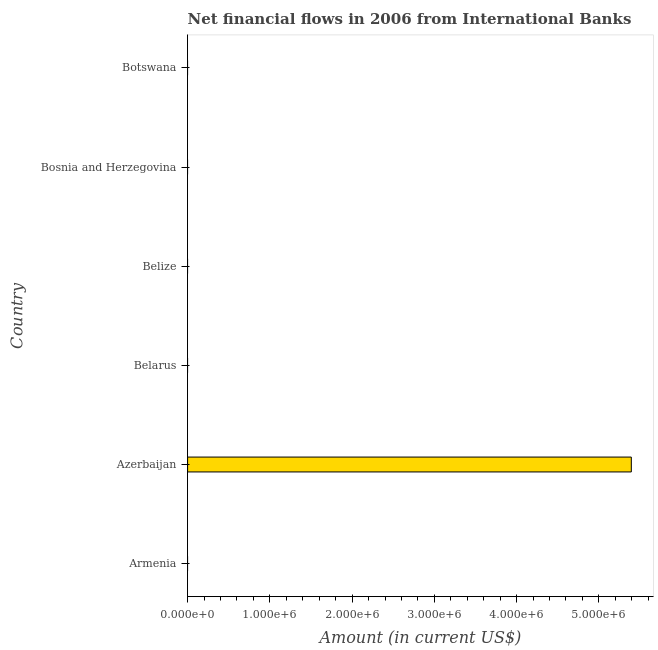Does the graph contain grids?
Make the answer very short. No. What is the title of the graph?
Offer a terse response. Net financial flows in 2006 from International Banks. What is the label or title of the X-axis?
Make the answer very short. Amount (in current US$). What is the label or title of the Y-axis?
Your answer should be very brief. Country. What is the net financial flows from ibrd in Azerbaijan?
Provide a succinct answer. 5.39e+06. Across all countries, what is the maximum net financial flows from ibrd?
Provide a succinct answer. 5.39e+06. In which country was the net financial flows from ibrd maximum?
Your answer should be very brief. Azerbaijan. What is the sum of the net financial flows from ibrd?
Provide a succinct answer. 5.39e+06. What is the average net financial flows from ibrd per country?
Ensure brevity in your answer.  8.99e+05. What is the median net financial flows from ibrd?
Offer a very short reply. 0. What is the difference between the highest and the lowest net financial flows from ibrd?
Offer a very short reply. 5.39e+06. How many countries are there in the graph?
Your response must be concise. 6. What is the difference between two consecutive major ticks on the X-axis?
Offer a very short reply. 1.00e+06. Are the values on the major ticks of X-axis written in scientific E-notation?
Keep it short and to the point. Yes. What is the Amount (in current US$) in Armenia?
Your answer should be very brief. 0. What is the Amount (in current US$) in Azerbaijan?
Your answer should be compact. 5.39e+06. What is the Amount (in current US$) in Belarus?
Keep it short and to the point. 0. What is the Amount (in current US$) in Botswana?
Ensure brevity in your answer.  0. 